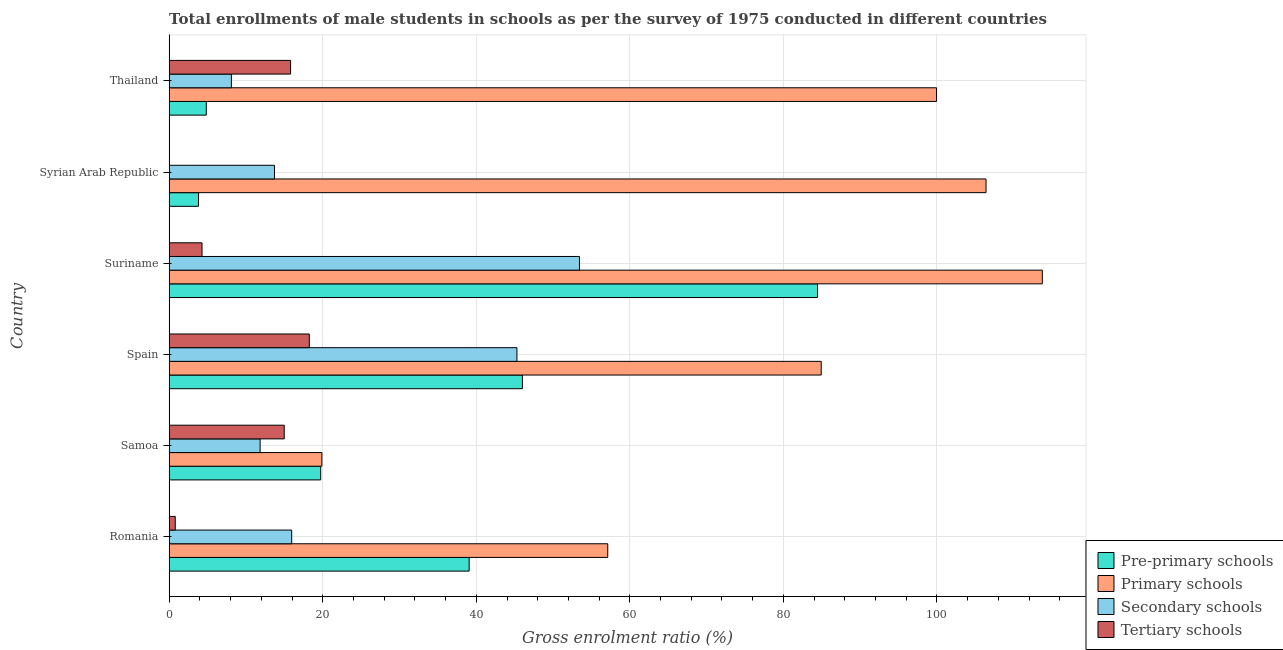Are the number of bars per tick equal to the number of legend labels?
Give a very brief answer. Yes. Are the number of bars on each tick of the Y-axis equal?
Keep it short and to the point. Yes. How many bars are there on the 5th tick from the top?
Offer a terse response. 4. How many bars are there on the 6th tick from the bottom?
Your answer should be very brief. 4. What is the label of the 5th group of bars from the top?
Your answer should be compact. Samoa. In how many cases, is the number of bars for a given country not equal to the number of legend labels?
Offer a terse response. 0. What is the gross enrolment ratio(male) in secondary schools in Syrian Arab Republic?
Your answer should be very brief. 13.72. Across all countries, what is the maximum gross enrolment ratio(male) in tertiary schools?
Provide a short and direct response. 18.25. Across all countries, what is the minimum gross enrolment ratio(male) in pre-primary schools?
Make the answer very short. 3.82. In which country was the gross enrolment ratio(male) in primary schools maximum?
Provide a succinct answer. Suriname. In which country was the gross enrolment ratio(male) in tertiary schools minimum?
Provide a short and direct response. Syrian Arab Republic. What is the total gross enrolment ratio(male) in pre-primary schools in the graph?
Your response must be concise. 197.89. What is the difference between the gross enrolment ratio(male) in tertiary schools in Spain and that in Thailand?
Offer a very short reply. 2.44. What is the difference between the gross enrolment ratio(male) in primary schools in Syrian Arab Republic and the gross enrolment ratio(male) in secondary schools in Thailand?
Your response must be concise. 98.29. What is the average gross enrolment ratio(male) in pre-primary schools per country?
Your answer should be very brief. 32.98. What is the difference between the gross enrolment ratio(male) in secondary schools and gross enrolment ratio(male) in pre-primary schools in Suriname?
Your response must be concise. -31.01. What is the ratio of the gross enrolment ratio(male) in pre-primary schools in Samoa to that in Suriname?
Provide a succinct answer. 0.23. Is the difference between the gross enrolment ratio(male) in primary schools in Spain and Syrian Arab Republic greater than the difference between the gross enrolment ratio(male) in pre-primary schools in Spain and Syrian Arab Republic?
Your answer should be compact. No. What is the difference between the highest and the second highest gross enrolment ratio(male) in primary schools?
Ensure brevity in your answer.  7.33. What is the difference between the highest and the lowest gross enrolment ratio(male) in secondary schools?
Keep it short and to the point. 45.34. In how many countries, is the gross enrolment ratio(male) in primary schools greater than the average gross enrolment ratio(male) in primary schools taken over all countries?
Provide a short and direct response. 4. Is the sum of the gross enrolment ratio(male) in primary schools in Romania and Syrian Arab Republic greater than the maximum gross enrolment ratio(male) in secondary schools across all countries?
Give a very brief answer. Yes. What does the 3rd bar from the top in Thailand represents?
Provide a short and direct response. Primary schools. What does the 2nd bar from the bottom in Romania represents?
Provide a succinct answer. Primary schools. Are all the bars in the graph horizontal?
Your answer should be compact. Yes. Are the values on the major ticks of X-axis written in scientific E-notation?
Offer a terse response. No. What is the title of the graph?
Provide a short and direct response. Total enrollments of male students in schools as per the survey of 1975 conducted in different countries. Does "Pre-primary schools" appear as one of the legend labels in the graph?
Offer a terse response. Yes. What is the label or title of the Y-axis?
Ensure brevity in your answer.  Country. What is the Gross enrolment ratio (%) of Pre-primary schools in Romania?
Keep it short and to the point. 39.07. What is the Gross enrolment ratio (%) in Primary schools in Romania?
Offer a terse response. 57.12. What is the Gross enrolment ratio (%) in Secondary schools in Romania?
Ensure brevity in your answer.  15.95. What is the Gross enrolment ratio (%) of Tertiary schools in Romania?
Offer a terse response. 0.79. What is the Gross enrolment ratio (%) in Pre-primary schools in Samoa?
Ensure brevity in your answer.  19.73. What is the Gross enrolment ratio (%) in Primary schools in Samoa?
Your answer should be very brief. 19.88. What is the Gross enrolment ratio (%) of Secondary schools in Samoa?
Offer a terse response. 11.84. What is the Gross enrolment ratio (%) of Tertiary schools in Samoa?
Give a very brief answer. 14.98. What is the Gross enrolment ratio (%) of Pre-primary schools in Spain?
Offer a very short reply. 46.01. What is the Gross enrolment ratio (%) of Primary schools in Spain?
Ensure brevity in your answer.  84.92. What is the Gross enrolment ratio (%) in Secondary schools in Spain?
Your response must be concise. 45.29. What is the Gross enrolment ratio (%) of Tertiary schools in Spain?
Give a very brief answer. 18.25. What is the Gross enrolment ratio (%) in Pre-primary schools in Suriname?
Your answer should be compact. 84.44. What is the Gross enrolment ratio (%) of Primary schools in Suriname?
Give a very brief answer. 113.72. What is the Gross enrolment ratio (%) in Secondary schools in Suriname?
Provide a short and direct response. 53.44. What is the Gross enrolment ratio (%) of Tertiary schools in Suriname?
Make the answer very short. 4.27. What is the Gross enrolment ratio (%) of Pre-primary schools in Syrian Arab Republic?
Your answer should be compact. 3.82. What is the Gross enrolment ratio (%) in Primary schools in Syrian Arab Republic?
Provide a succinct answer. 106.39. What is the Gross enrolment ratio (%) in Secondary schools in Syrian Arab Republic?
Your answer should be compact. 13.72. What is the Gross enrolment ratio (%) of Tertiary schools in Syrian Arab Republic?
Offer a terse response. 0.02. What is the Gross enrolment ratio (%) in Pre-primary schools in Thailand?
Provide a succinct answer. 4.83. What is the Gross enrolment ratio (%) of Primary schools in Thailand?
Provide a succinct answer. 99.95. What is the Gross enrolment ratio (%) of Secondary schools in Thailand?
Provide a succinct answer. 8.1. What is the Gross enrolment ratio (%) in Tertiary schools in Thailand?
Your answer should be very brief. 15.81. Across all countries, what is the maximum Gross enrolment ratio (%) in Pre-primary schools?
Your answer should be compact. 84.44. Across all countries, what is the maximum Gross enrolment ratio (%) in Primary schools?
Your answer should be compact. 113.72. Across all countries, what is the maximum Gross enrolment ratio (%) in Secondary schools?
Keep it short and to the point. 53.44. Across all countries, what is the maximum Gross enrolment ratio (%) of Tertiary schools?
Your response must be concise. 18.25. Across all countries, what is the minimum Gross enrolment ratio (%) in Pre-primary schools?
Keep it short and to the point. 3.82. Across all countries, what is the minimum Gross enrolment ratio (%) of Primary schools?
Make the answer very short. 19.88. Across all countries, what is the minimum Gross enrolment ratio (%) of Secondary schools?
Provide a succinct answer. 8.1. Across all countries, what is the minimum Gross enrolment ratio (%) in Tertiary schools?
Ensure brevity in your answer.  0.02. What is the total Gross enrolment ratio (%) of Pre-primary schools in the graph?
Provide a succinct answer. 197.89. What is the total Gross enrolment ratio (%) of Primary schools in the graph?
Keep it short and to the point. 481.99. What is the total Gross enrolment ratio (%) in Secondary schools in the graph?
Your answer should be very brief. 148.34. What is the total Gross enrolment ratio (%) of Tertiary schools in the graph?
Offer a very short reply. 54.12. What is the difference between the Gross enrolment ratio (%) of Pre-primary schools in Romania and that in Samoa?
Offer a very short reply. 19.34. What is the difference between the Gross enrolment ratio (%) of Primary schools in Romania and that in Samoa?
Make the answer very short. 37.24. What is the difference between the Gross enrolment ratio (%) in Secondary schools in Romania and that in Samoa?
Offer a very short reply. 4.11. What is the difference between the Gross enrolment ratio (%) of Tertiary schools in Romania and that in Samoa?
Provide a succinct answer. -14.19. What is the difference between the Gross enrolment ratio (%) in Pre-primary schools in Romania and that in Spain?
Your response must be concise. -6.94. What is the difference between the Gross enrolment ratio (%) in Primary schools in Romania and that in Spain?
Provide a succinct answer. -27.8. What is the difference between the Gross enrolment ratio (%) of Secondary schools in Romania and that in Spain?
Your answer should be compact. -29.34. What is the difference between the Gross enrolment ratio (%) of Tertiary schools in Romania and that in Spain?
Provide a short and direct response. -17.46. What is the difference between the Gross enrolment ratio (%) of Pre-primary schools in Romania and that in Suriname?
Your answer should be compact. -45.38. What is the difference between the Gross enrolment ratio (%) in Primary schools in Romania and that in Suriname?
Offer a very short reply. -56.6. What is the difference between the Gross enrolment ratio (%) of Secondary schools in Romania and that in Suriname?
Give a very brief answer. -37.48. What is the difference between the Gross enrolment ratio (%) in Tertiary schools in Romania and that in Suriname?
Give a very brief answer. -3.49. What is the difference between the Gross enrolment ratio (%) of Pre-primary schools in Romania and that in Syrian Arab Republic?
Ensure brevity in your answer.  35.25. What is the difference between the Gross enrolment ratio (%) of Primary schools in Romania and that in Syrian Arab Republic?
Offer a very short reply. -49.27. What is the difference between the Gross enrolment ratio (%) of Secondary schools in Romania and that in Syrian Arab Republic?
Give a very brief answer. 2.24. What is the difference between the Gross enrolment ratio (%) of Tertiary schools in Romania and that in Syrian Arab Republic?
Your answer should be very brief. 0.77. What is the difference between the Gross enrolment ratio (%) of Pre-primary schools in Romania and that in Thailand?
Make the answer very short. 34.24. What is the difference between the Gross enrolment ratio (%) in Primary schools in Romania and that in Thailand?
Make the answer very short. -42.83. What is the difference between the Gross enrolment ratio (%) in Secondary schools in Romania and that in Thailand?
Offer a very short reply. 7.86. What is the difference between the Gross enrolment ratio (%) of Tertiary schools in Romania and that in Thailand?
Your response must be concise. -15.02. What is the difference between the Gross enrolment ratio (%) in Pre-primary schools in Samoa and that in Spain?
Keep it short and to the point. -26.28. What is the difference between the Gross enrolment ratio (%) of Primary schools in Samoa and that in Spain?
Your response must be concise. -65.04. What is the difference between the Gross enrolment ratio (%) in Secondary schools in Samoa and that in Spain?
Your answer should be compact. -33.45. What is the difference between the Gross enrolment ratio (%) in Tertiary schools in Samoa and that in Spain?
Make the answer very short. -3.27. What is the difference between the Gross enrolment ratio (%) of Pre-primary schools in Samoa and that in Suriname?
Offer a terse response. -64.71. What is the difference between the Gross enrolment ratio (%) in Primary schools in Samoa and that in Suriname?
Offer a terse response. -93.84. What is the difference between the Gross enrolment ratio (%) of Secondary schools in Samoa and that in Suriname?
Your answer should be very brief. -41.6. What is the difference between the Gross enrolment ratio (%) of Tertiary schools in Samoa and that in Suriname?
Provide a succinct answer. 10.71. What is the difference between the Gross enrolment ratio (%) of Pre-primary schools in Samoa and that in Syrian Arab Republic?
Offer a very short reply. 15.92. What is the difference between the Gross enrolment ratio (%) of Primary schools in Samoa and that in Syrian Arab Republic?
Ensure brevity in your answer.  -86.51. What is the difference between the Gross enrolment ratio (%) of Secondary schools in Samoa and that in Syrian Arab Republic?
Make the answer very short. -1.88. What is the difference between the Gross enrolment ratio (%) in Tertiary schools in Samoa and that in Syrian Arab Republic?
Your answer should be compact. 14.96. What is the difference between the Gross enrolment ratio (%) in Pre-primary schools in Samoa and that in Thailand?
Keep it short and to the point. 14.9. What is the difference between the Gross enrolment ratio (%) of Primary schools in Samoa and that in Thailand?
Make the answer very short. -80.06. What is the difference between the Gross enrolment ratio (%) of Secondary schools in Samoa and that in Thailand?
Ensure brevity in your answer.  3.74. What is the difference between the Gross enrolment ratio (%) of Tertiary schools in Samoa and that in Thailand?
Make the answer very short. -0.83. What is the difference between the Gross enrolment ratio (%) of Pre-primary schools in Spain and that in Suriname?
Make the answer very short. -38.44. What is the difference between the Gross enrolment ratio (%) of Primary schools in Spain and that in Suriname?
Offer a terse response. -28.8. What is the difference between the Gross enrolment ratio (%) of Secondary schools in Spain and that in Suriname?
Your answer should be compact. -8.14. What is the difference between the Gross enrolment ratio (%) of Tertiary schools in Spain and that in Suriname?
Keep it short and to the point. 13.98. What is the difference between the Gross enrolment ratio (%) of Pre-primary schools in Spain and that in Syrian Arab Republic?
Your answer should be compact. 42.19. What is the difference between the Gross enrolment ratio (%) of Primary schools in Spain and that in Syrian Arab Republic?
Ensure brevity in your answer.  -21.47. What is the difference between the Gross enrolment ratio (%) of Secondary schools in Spain and that in Syrian Arab Republic?
Give a very brief answer. 31.58. What is the difference between the Gross enrolment ratio (%) of Tertiary schools in Spain and that in Syrian Arab Republic?
Offer a very short reply. 18.23. What is the difference between the Gross enrolment ratio (%) in Pre-primary schools in Spain and that in Thailand?
Provide a short and direct response. 41.18. What is the difference between the Gross enrolment ratio (%) in Primary schools in Spain and that in Thailand?
Offer a very short reply. -15.02. What is the difference between the Gross enrolment ratio (%) of Secondary schools in Spain and that in Thailand?
Offer a terse response. 37.19. What is the difference between the Gross enrolment ratio (%) of Tertiary schools in Spain and that in Thailand?
Provide a succinct answer. 2.44. What is the difference between the Gross enrolment ratio (%) of Pre-primary schools in Suriname and that in Syrian Arab Republic?
Your answer should be very brief. 80.63. What is the difference between the Gross enrolment ratio (%) in Primary schools in Suriname and that in Syrian Arab Republic?
Offer a very short reply. 7.33. What is the difference between the Gross enrolment ratio (%) in Secondary schools in Suriname and that in Syrian Arab Republic?
Keep it short and to the point. 39.72. What is the difference between the Gross enrolment ratio (%) of Tertiary schools in Suriname and that in Syrian Arab Republic?
Your answer should be compact. 4.26. What is the difference between the Gross enrolment ratio (%) of Pre-primary schools in Suriname and that in Thailand?
Your answer should be very brief. 79.61. What is the difference between the Gross enrolment ratio (%) of Primary schools in Suriname and that in Thailand?
Keep it short and to the point. 13.78. What is the difference between the Gross enrolment ratio (%) in Secondary schools in Suriname and that in Thailand?
Your answer should be compact. 45.34. What is the difference between the Gross enrolment ratio (%) in Tertiary schools in Suriname and that in Thailand?
Keep it short and to the point. -11.53. What is the difference between the Gross enrolment ratio (%) in Pre-primary schools in Syrian Arab Republic and that in Thailand?
Give a very brief answer. -1.01. What is the difference between the Gross enrolment ratio (%) of Primary schools in Syrian Arab Republic and that in Thailand?
Make the answer very short. 6.44. What is the difference between the Gross enrolment ratio (%) of Secondary schools in Syrian Arab Republic and that in Thailand?
Make the answer very short. 5.62. What is the difference between the Gross enrolment ratio (%) of Tertiary schools in Syrian Arab Republic and that in Thailand?
Offer a terse response. -15.79. What is the difference between the Gross enrolment ratio (%) in Pre-primary schools in Romania and the Gross enrolment ratio (%) in Primary schools in Samoa?
Give a very brief answer. 19.18. What is the difference between the Gross enrolment ratio (%) of Pre-primary schools in Romania and the Gross enrolment ratio (%) of Secondary schools in Samoa?
Give a very brief answer. 27.23. What is the difference between the Gross enrolment ratio (%) in Pre-primary schools in Romania and the Gross enrolment ratio (%) in Tertiary schools in Samoa?
Your response must be concise. 24.09. What is the difference between the Gross enrolment ratio (%) in Primary schools in Romania and the Gross enrolment ratio (%) in Secondary schools in Samoa?
Make the answer very short. 45.28. What is the difference between the Gross enrolment ratio (%) in Primary schools in Romania and the Gross enrolment ratio (%) in Tertiary schools in Samoa?
Offer a terse response. 42.14. What is the difference between the Gross enrolment ratio (%) of Secondary schools in Romania and the Gross enrolment ratio (%) of Tertiary schools in Samoa?
Provide a short and direct response. 0.97. What is the difference between the Gross enrolment ratio (%) in Pre-primary schools in Romania and the Gross enrolment ratio (%) in Primary schools in Spain?
Offer a terse response. -45.85. What is the difference between the Gross enrolment ratio (%) in Pre-primary schools in Romania and the Gross enrolment ratio (%) in Secondary schools in Spain?
Provide a short and direct response. -6.22. What is the difference between the Gross enrolment ratio (%) in Pre-primary schools in Romania and the Gross enrolment ratio (%) in Tertiary schools in Spain?
Provide a short and direct response. 20.82. What is the difference between the Gross enrolment ratio (%) in Primary schools in Romania and the Gross enrolment ratio (%) in Secondary schools in Spain?
Your answer should be compact. 11.83. What is the difference between the Gross enrolment ratio (%) of Primary schools in Romania and the Gross enrolment ratio (%) of Tertiary schools in Spain?
Provide a succinct answer. 38.87. What is the difference between the Gross enrolment ratio (%) in Secondary schools in Romania and the Gross enrolment ratio (%) in Tertiary schools in Spain?
Ensure brevity in your answer.  -2.3. What is the difference between the Gross enrolment ratio (%) of Pre-primary schools in Romania and the Gross enrolment ratio (%) of Primary schools in Suriname?
Your answer should be very brief. -74.66. What is the difference between the Gross enrolment ratio (%) in Pre-primary schools in Romania and the Gross enrolment ratio (%) in Secondary schools in Suriname?
Offer a very short reply. -14.37. What is the difference between the Gross enrolment ratio (%) in Pre-primary schools in Romania and the Gross enrolment ratio (%) in Tertiary schools in Suriname?
Provide a succinct answer. 34.79. What is the difference between the Gross enrolment ratio (%) in Primary schools in Romania and the Gross enrolment ratio (%) in Secondary schools in Suriname?
Your answer should be very brief. 3.68. What is the difference between the Gross enrolment ratio (%) in Primary schools in Romania and the Gross enrolment ratio (%) in Tertiary schools in Suriname?
Give a very brief answer. 52.85. What is the difference between the Gross enrolment ratio (%) in Secondary schools in Romania and the Gross enrolment ratio (%) in Tertiary schools in Suriname?
Your answer should be very brief. 11.68. What is the difference between the Gross enrolment ratio (%) in Pre-primary schools in Romania and the Gross enrolment ratio (%) in Primary schools in Syrian Arab Republic?
Your response must be concise. -67.32. What is the difference between the Gross enrolment ratio (%) in Pre-primary schools in Romania and the Gross enrolment ratio (%) in Secondary schools in Syrian Arab Republic?
Your answer should be compact. 25.35. What is the difference between the Gross enrolment ratio (%) in Pre-primary schools in Romania and the Gross enrolment ratio (%) in Tertiary schools in Syrian Arab Republic?
Your answer should be very brief. 39.05. What is the difference between the Gross enrolment ratio (%) of Primary schools in Romania and the Gross enrolment ratio (%) of Secondary schools in Syrian Arab Republic?
Ensure brevity in your answer.  43.41. What is the difference between the Gross enrolment ratio (%) of Primary schools in Romania and the Gross enrolment ratio (%) of Tertiary schools in Syrian Arab Republic?
Ensure brevity in your answer.  57.1. What is the difference between the Gross enrolment ratio (%) of Secondary schools in Romania and the Gross enrolment ratio (%) of Tertiary schools in Syrian Arab Republic?
Keep it short and to the point. 15.94. What is the difference between the Gross enrolment ratio (%) in Pre-primary schools in Romania and the Gross enrolment ratio (%) in Primary schools in Thailand?
Make the answer very short. -60.88. What is the difference between the Gross enrolment ratio (%) of Pre-primary schools in Romania and the Gross enrolment ratio (%) of Secondary schools in Thailand?
Provide a succinct answer. 30.97. What is the difference between the Gross enrolment ratio (%) of Pre-primary schools in Romania and the Gross enrolment ratio (%) of Tertiary schools in Thailand?
Keep it short and to the point. 23.26. What is the difference between the Gross enrolment ratio (%) of Primary schools in Romania and the Gross enrolment ratio (%) of Secondary schools in Thailand?
Offer a terse response. 49.02. What is the difference between the Gross enrolment ratio (%) in Primary schools in Romania and the Gross enrolment ratio (%) in Tertiary schools in Thailand?
Ensure brevity in your answer.  41.31. What is the difference between the Gross enrolment ratio (%) of Secondary schools in Romania and the Gross enrolment ratio (%) of Tertiary schools in Thailand?
Provide a short and direct response. 0.15. What is the difference between the Gross enrolment ratio (%) of Pre-primary schools in Samoa and the Gross enrolment ratio (%) of Primary schools in Spain?
Ensure brevity in your answer.  -65.19. What is the difference between the Gross enrolment ratio (%) in Pre-primary schools in Samoa and the Gross enrolment ratio (%) in Secondary schools in Spain?
Ensure brevity in your answer.  -25.56. What is the difference between the Gross enrolment ratio (%) of Pre-primary schools in Samoa and the Gross enrolment ratio (%) of Tertiary schools in Spain?
Provide a succinct answer. 1.48. What is the difference between the Gross enrolment ratio (%) in Primary schools in Samoa and the Gross enrolment ratio (%) in Secondary schools in Spain?
Your response must be concise. -25.41. What is the difference between the Gross enrolment ratio (%) of Primary schools in Samoa and the Gross enrolment ratio (%) of Tertiary schools in Spain?
Ensure brevity in your answer.  1.63. What is the difference between the Gross enrolment ratio (%) of Secondary schools in Samoa and the Gross enrolment ratio (%) of Tertiary schools in Spain?
Your response must be concise. -6.41. What is the difference between the Gross enrolment ratio (%) of Pre-primary schools in Samoa and the Gross enrolment ratio (%) of Primary schools in Suriname?
Offer a very short reply. -93.99. What is the difference between the Gross enrolment ratio (%) in Pre-primary schools in Samoa and the Gross enrolment ratio (%) in Secondary schools in Suriname?
Offer a very short reply. -33.71. What is the difference between the Gross enrolment ratio (%) of Pre-primary schools in Samoa and the Gross enrolment ratio (%) of Tertiary schools in Suriname?
Offer a very short reply. 15.46. What is the difference between the Gross enrolment ratio (%) of Primary schools in Samoa and the Gross enrolment ratio (%) of Secondary schools in Suriname?
Provide a short and direct response. -33.55. What is the difference between the Gross enrolment ratio (%) in Primary schools in Samoa and the Gross enrolment ratio (%) in Tertiary schools in Suriname?
Your answer should be compact. 15.61. What is the difference between the Gross enrolment ratio (%) of Secondary schools in Samoa and the Gross enrolment ratio (%) of Tertiary schools in Suriname?
Your response must be concise. 7.57. What is the difference between the Gross enrolment ratio (%) in Pre-primary schools in Samoa and the Gross enrolment ratio (%) in Primary schools in Syrian Arab Republic?
Your answer should be very brief. -86.66. What is the difference between the Gross enrolment ratio (%) of Pre-primary schools in Samoa and the Gross enrolment ratio (%) of Secondary schools in Syrian Arab Republic?
Offer a very short reply. 6.02. What is the difference between the Gross enrolment ratio (%) in Pre-primary schools in Samoa and the Gross enrolment ratio (%) in Tertiary schools in Syrian Arab Republic?
Your answer should be very brief. 19.71. What is the difference between the Gross enrolment ratio (%) in Primary schools in Samoa and the Gross enrolment ratio (%) in Secondary schools in Syrian Arab Republic?
Your response must be concise. 6.17. What is the difference between the Gross enrolment ratio (%) of Primary schools in Samoa and the Gross enrolment ratio (%) of Tertiary schools in Syrian Arab Republic?
Your answer should be compact. 19.87. What is the difference between the Gross enrolment ratio (%) in Secondary schools in Samoa and the Gross enrolment ratio (%) in Tertiary schools in Syrian Arab Republic?
Provide a succinct answer. 11.82. What is the difference between the Gross enrolment ratio (%) of Pre-primary schools in Samoa and the Gross enrolment ratio (%) of Primary schools in Thailand?
Ensure brevity in your answer.  -80.22. What is the difference between the Gross enrolment ratio (%) in Pre-primary schools in Samoa and the Gross enrolment ratio (%) in Secondary schools in Thailand?
Make the answer very short. 11.63. What is the difference between the Gross enrolment ratio (%) of Pre-primary schools in Samoa and the Gross enrolment ratio (%) of Tertiary schools in Thailand?
Give a very brief answer. 3.92. What is the difference between the Gross enrolment ratio (%) of Primary schools in Samoa and the Gross enrolment ratio (%) of Secondary schools in Thailand?
Offer a very short reply. 11.79. What is the difference between the Gross enrolment ratio (%) in Primary schools in Samoa and the Gross enrolment ratio (%) in Tertiary schools in Thailand?
Your response must be concise. 4.08. What is the difference between the Gross enrolment ratio (%) in Secondary schools in Samoa and the Gross enrolment ratio (%) in Tertiary schools in Thailand?
Offer a very short reply. -3.97. What is the difference between the Gross enrolment ratio (%) in Pre-primary schools in Spain and the Gross enrolment ratio (%) in Primary schools in Suriname?
Offer a terse response. -67.72. What is the difference between the Gross enrolment ratio (%) in Pre-primary schools in Spain and the Gross enrolment ratio (%) in Secondary schools in Suriname?
Your answer should be very brief. -7.43. What is the difference between the Gross enrolment ratio (%) in Pre-primary schools in Spain and the Gross enrolment ratio (%) in Tertiary schools in Suriname?
Your answer should be compact. 41.73. What is the difference between the Gross enrolment ratio (%) in Primary schools in Spain and the Gross enrolment ratio (%) in Secondary schools in Suriname?
Ensure brevity in your answer.  31.48. What is the difference between the Gross enrolment ratio (%) of Primary schools in Spain and the Gross enrolment ratio (%) of Tertiary schools in Suriname?
Offer a very short reply. 80.65. What is the difference between the Gross enrolment ratio (%) in Secondary schools in Spain and the Gross enrolment ratio (%) in Tertiary schools in Suriname?
Give a very brief answer. 41.02. What is the difference between the Gross enrolment ratio (%) of Pre-primary schools in Spain and the Gross enrolment ratio (%) of Primary schools in Syrian Arab Republic?
Give a very brief answer. -60.38. What is the difference between the Gross enrolment ratio (%) of Pre-primary schools in Spain and the Gross enrolment ratio (%) of Secondary schools in Syrian Arab Republic?
Ensure brevity in your answer.  32.29. What is the difference between the Gross enrolment ratio (%) in Pre-primary schools in Spain and the Gross enrolment ratio (%) in Tertiary schools in Syrian Arab Republic?
Give a very brief answer. 45.99. What is the difference between the Gross enrolment ratio (%) in Primary schools in Spain and the Gross enrolment ratio (%) in Secondary schools in Syrian Arab Republic?
Offer a very short reply. 71.21. What is the difference between the Gross enrolment ratio (%) in Primary schools in Spain and the Gross enrolment ratio (%) in Tertiary schools in Syrian Arab Republic?
Your answer should be compact. 84.9. What is the difference between the Gross enrolment ratio (%) in Secondary schools in Spain and the Gross enrolment ratio (%) in Tertiary schools in Syrian Arab Republic?
Your answer should be compact. 45.27. What is the difference between the Gross enrolment ratio (%) in Pre-primary schools in Spain and the Gross enrolment ratio (%) in Primary schools in Thailand?
Make the answer very short. -53.94. What is the difference between the Gross enrolment ratio (%) of Pre-primary schools in Spain and the Gross enrolment ratio (%) of Secondary schools in Thailand?
Your answer should be compact. 37.91. What is the difference between the Gross enrolment ratio (%) in Pre-primary schools in Spain and the Gross enrolment ratio (%) in Tertiary schools in Thailand?
Keep it short and to the point. 30.2. What is the difference between the Gross enrolment ratio (%) in Primary schools in Spain and the Gross enrolment ratio (%) in Secondary schools in Thailand?
Offer a terse response. 76.82. What is the difference between the Gross enrolment ratio (%) in Primary schools in Spain and the Gross enrolment ratio (%) in Tertiary schools in Thailand?
Provide a succinct answer. 69.11. What is the difference between the Gross enrolment ratio (%) in Secondary schools in Spain and the Gross enrolment ratio (%) in Tertiary schools in Thailand?
Make the answer very short. 29.48. What is the difference between the Gross enrolment ratio (%) of Pre-primary schools in Suriname and the Gross enrolment ratio (%) of Primary schools in Syrian Arab Republic?
Give a very brief answer. -21.95. What is the difference between the Gross enrolment ratio (%) of Pre-primary schools in Suriname and the Gross enrolment ratio (%) of Secondary schools in Syrian Arab Republic?
Keep it short and to the point. 70.73. What is the difference between the Gross enrolment ratio (%) in Pre-primary schools in Suriname and the Gross enrolment ratio (%) in Tertiary schools in Syrian Arab Republic?
Your response must be concise. 84.43. What is the difference between the Gross enrolment ratio (%) in Primary schools in Suriname and the Gross enrolment ratio (%) in Secondary schools in Syrian Arab Republic?
Your answer should be compact. 100.01. What is the difference between the Gross enrolment ratio (%) in Primary schools in Suriname and the Gross enrolment ratio (%) in Tertiary schools in Syrian Arab Republic?
Provide a succinct answer. 113.71. What is the difference between the Gross enrolment ratio (%) in Secondary schools in Suriname and the Gross enrolment ratio (%) in Tertiary schools in Syrian Arab Republic?
Make the answer very short. 53.42. What is the difference between the Gross enrolment ratio (%) in Pre-primary schools in Suriname and the Gross enrolment ratio (%) in Primary schools in Thailand?
Your answer should be compact. -15.5. What is the difference between the Gross enrolment ratio (%) of Pre-primary schools in Suriname and the Gross enrolment ratio (%) of Secondary schools in Thailand?
Your answer should be very brief. 76.34. What is the difference between the Gross enrolment ratio (%) of Pre-primary schools in Suriname and the Gross enrolment ratio (%) of Tertiary schools in Thailand?
Your response must be concise. 68.64. What is the difference between the Gross enrolment ratio (%) of Primary schools in Suriname and the Gross enrolment ratio (%) of Secondary schools in Thailand?
Provide a succinct answer. 105.63. What is the difference between the Gross enrolment ratio (%) of Primary schools in Suriname and the Gross enrolment ratio (%) of Tertiary schools in Thailand?
Your answer should be very brief. 97.92. What is the difference between the Gross enrolment ratio (%) in Secondary schools in Suriname and the Gross enrolment ratio (%) in Tertiary schools in Thailand?
Your response must be concise. 37.63. What is the difference between the Gross enrolment ratio (%) in Pre-primary schools in Syrian Arab Republic and the Gross enrolment ratio (%) in Primary schools in Thailand?
Make the answer very short. -96.13. What is the difference between the Gross enrolment ratio (%) of Pre-primary schools in Syrian Arab Republic and the Gross enrolment ratio (%) of Secondary schools in Thailand?
Your response must be concise. -4.28. What is the difference between the Gross enrolment ratio (%) of Pre-primary schools in Syrian Arab Republic and the Gross enrolment ratio (%) of Tertiary schools in Thailand?
Offer a terse response. -11.99. What is the difference between the Gross enrolment ratio (%) in Primary schools in Syrian Arab Republic and the Gross enrolment ratio (%) in Secondary schools in Thailand?
Make the answer very short. 98.29. What is the difference between the Gross enrolment ratio (%) of Primary schools in Syrian Arab Republic and the Gross enrolment ratio (%) of Tertiary schools in Thailand?
Provide a succinct answer. 90.58. What is the difference between the Gross enrolment ratio (%) in Secondary schools in Syrian Arab Republic and the Gross enrolment ratio (%) in Tertiary schools in Thailand?
Provide a succinct answer. -2.09. What is the average Gross enrolment ratio (%) in Pre-primary schools per country?
Your response must be concise. 32.98. What is the average Gross enrolment ratio (%) of Primary schools per country?
Your answer should be very brief. 80.33. What is the average Gross enrolment ratio (%) of Secondary schools per country?
Ensure brevity in your answer.  24.72. What is the average Gross enrolment ratio (%) of Tertiary schools per country?
Your answer should be very brief. 9.02. What is the difference between the Gross enrolment ratio (%) in Pre-primary schools and Gross enrolment ratio (%) in Primary schools in Romania?
Your answer should be very brief. -18.05. What is the difference between the Gross enrolment ratio (%) of Pre-primary schools and Gross enrolment ratio (%) of Secondary schools in Romania?
Ensure brevity in your answer.  23.11. What is the difference between the Gross enrolment ratio (%) in Pre-primary schools and Gross enrolment ratio (%) in Tertiary schools in Romania?
Provide a short and direct response. 38.28. What is the difference between the Gross enrolment ratio (%) of Primary schools and Gross enrolment ratio (%) of Secondary schools in Romania?
Keep it short and to the point. 41.17. What is the difference between the Gross enrolment ratio (%) in Primary schools and Gross enrolment ratio (%) in Tertiary schools in Romania?
Provide a succinct answer. 56.33. What is the difference between the Gross enrolment ratio (%) of Secondary schools and Gross enrolment ratio (%) of Tertiary schools in Romania?
Your answer should be compact. 15.17. What is the difference between the Gross enrolment ratio (%) of Pre-primary schools and Gross enrolment ratio (%) of Primary schools in Samoa?
Your response must be concise. -0.15. What is the difference between the Gross enrolment ratio (%) in Pre-primary schools and Gross enrolment ratio (%) in Secondary schools in Samoa?
Keep it short and to the point. 7.89. What is the difference between the Gross enrolment ratio (%) of Pre-primary schools and Gross enrolment ratio (%) of Tertiary schools in Samoa?
Provide a short and direct response. 4.75. What is the difference between the Gross enrolment ratio (%) of Primary schools and Gross enrolment ratio (%) of Secondary schools in Samoa?
Make the answer very short. 8.04. What is the difference between the Gross enrolment ratio (%) in Primary schools and Gross enrolment ratio (%) in Tertiary schools in Samoa?
Your answer should be compact. 4.9. What is the difference between the Gross enrolment ratio (%) in Secondary schools and Gross enrolment ratio (%) in Tertiary schools in Samoa?
Your response must be concise. -3.14. What is the difference between the Gross enrolment ratio (%) in Pre-primary schools and Gross enrolment ratio (%) in Primary schools in Spain?
Offer a terse response. -38.92. What is the difference between the Gross enrolment ratio (%) in Pre-primary schools and Gross enrolment ratio (%) in Secondary schools in Spain?
Offer a terse response. 0.71. What is the difference between the Gross enrolment ratio (%) in Pre-primary schools and Gross enrolment ratio (%) in Tertiary schools in Spain?
Your answer should be very brief. 27.76. What is the difference between the Gross enrolment ratio (%) of Primary schools and Gross enrolment ratio (%) of Secondary schools in Spain?
Offer a very short reply. 39.63. What is the difference between the Gross enrolment ratio (%) of Primary schools and Gross enrolment ratio (%) of Tertiary schools in Spain?
Your answer should be very brief. 66.67. What is the difference between the Gross enrolment ratio (%) of Secondary schools and Gross enrolment ratio (%) of Tertiary schools in Spain?
Ensure brevity in your answer.  27.04. What is the difference between the Gross enrolment ratio (%) in Pre-primary schools and Gross enrolment ratio (%) in Primary schools in Suriname?
Your answer should be compact. -29.28. What is the difference between the Gross enrolment ratio (%) of Pre-primary schools and Gross enrolment ratio (%) of Secondary schools in Suriname?
Keep it short and to the point. 31.01. What is the difference between the Gross enrolment ratio (%) of Pre-primary schools and Gross enrolment ratio (%) of Tertiary schools in Suriname?
Ensure brevity in your answer.  80.17. What is the difference between the Gross enrolment ratio (%) in Primary schools and Gross enrolment ratio (%) in Secondary schools in Suriname?
Keep it short and to the point. 60.29. What is the difference between the Gross enrolment ratio (%) of Primary schools and Gross enrolment ratio (%) of Tertiary schools in Suriname?
Your answer should be very brief. 109.45. What is the difference between the Gross enrolment ratio (%) of Secondary schools and Gross enrolment ratio (%) of Tertiary schools in Suriname?
Offer a terse response. 49.16. What is the difference between the Gross enrolment ratio (%) of Pre-primary schools and Gross enrolment ratio (%) of Primary schools in Syrian Arab Republic?
Your answer should be compact. -102.58. What is the difference between the Gross enrolment ratio (%) of Pre-primary schools and Gross enrolment ratio (%) of Secondary schools in Syrian Arab Republic?
Offer a very short reply. -9.9. What is the difference between the Gross enrolment ratio (%) of Pre-primary schools and Gross enrolment ratio (%) of Tertiary schools in Syrian Arab Republic?
Your answer should be very brief. 3.8. What is the difference between the Gross enrolment ratio (%) of Primary schools and Gross enrolment ratio (%) of Secondary schools in Syrian Arab Republic?
Your answer should be compact. 92.68. What is the difference between the Gross enrolment ratio (%) of Primary schools and Gross enrolment ratio (%) of Tertiary schools in Syrian Arab Republic?
Offer a very short reply. 106.37. What is the difference between the Gross enrolment ratio (%) in Secondary schools and Gross enrolment ratio (%) in Tertiary schools in Syrian Arab Republic?
Make the answer very short. 13.7. What is the difference between the Gross enrolment ratio (%) in Pre-primary schools and Gross enrolment ratio (%) in Primary schools in Thailand?
Keep it short and to the point. -95.12. What is the difference between the Gross enrolment ratio (%) of Pre-primary schools and Gross enrolment ratio (%) of Secondary schools in Thailand?
Your answer should be compact. -3.27. What is the difference between the Gross enrolment ratio (%) of Pre-primary schools and Gross enrolment ratio (%) of Tertiary schools in Thailand?
Ensure brevity in your answer.  -10.98. What is the difference between the Gross enrolment ratio (%) of Primary schools and Gross enrolment ratio (%) of Secondary schools in Thailand?
Keep it short and to the point. 91.85. What is the difference between the Gross enrolment ratio (%) of Primary schools and Gross enrolment ratio (%) of Tertiary schools in Thailand?
Your answer should be compact. 84.14. What is the difference between the Gross enrolment ratio (%) of Secondary schools and Gross enrolment ratio (%) of Tertiary schools in Thailand?
Your answer should be compact. -7.71. What is the ratio of the Gross enrolment ratio (%) in Pre-primary schools in Romania to that in Samoa?
Provide a short and direct response. 1.98. What is the ratio of the Gross enrolment ratio (%) of Primary schools in Romania to that in Samoa?
Give a very brief answer. 2.87. What is the ratio of the Gross enrolment ratio (%) of Secondary schools in Romania to that in Samoa?
Your answer should be compact. 1.35. What is the ratio of the Gross enrolment ratio (%) of Tertiary schools in Romania to that in Samoa?
Keep it short and to the point. 0.05. What is the ratio of the Gross enrolment ratio (%) in Pre-primary schools in Romania to that in Spain?
Your answer should be very brief. 0.85. What is the ratio of the Gross enrolment ratio (%) in Primary schools in Romania to that in Spain?
Keep it short and to the point. 0.67. What is the ratio of the Gross enrolment ratio (%) in Secondary schools in Romania to that in Spain?
Give a very brief answer. 0.35. What is the ratio of the Gross enrolment ratio (%) of Tertiary schools in Romania to that in Spain?
Offer a very short reply. 0.04. What is the ratio of the Gross enrolment ratio (%) in Pre-primary schools in Romania to that in Suriname?
Keep it short and to the point. 0.46. What is the ratio of the Gross enrolment ratio (%) in Primary schools in Romania to that in Suriname?
Offer a very short reply. 0.5. What is the ratio of the Gross enrolment ratio (%) of Secondary schools in Romania to that in Suriname?
Give a very brief answer. 0.3. What is the ratio of the Gross enrolment ratio (%) in Tertiary schools in Romania to that in Suriname?
Keep it short and to the point. 0.18. What is the ratio of the Gross enrolment ratio (%) of Pre-primary schools in Romania to that in Syrian Arab Republic?
Provide a succinct answer. 10.24. What is the ratio of the Gross enrolment ratio (%) in Primary schools in Romania to that in Syrian Arab Republic?
Your response must be concise. 0.54. What is the ratio of the Gross enrolment ratio (%) of Secondary schools in Romania to that in Syrian Arab Republic?
Your answer should be very brief. 1.16. What is the ratio of the Gross enrolment ratio (%) of Tertiary schools in Romania to that in Syrian Arab Republic?
Your answer should be compact. 43. What is the ratio of the Gross enrolment ratio (%) of Pre-primary schools in Romania to that in Thailand?
Your answer should be compact. 8.09. What is the ratio of the Gross enrolment ratio (%) of Primary schools in Romania to that in Thailand?
Your answer should be compact. 0.57. What is the ratio of the Gross enrolment ratio (%) in Secondary schools in Romania to that in Thailand?
Make the answer very short. 1.97. What is the ratio of the Gross enrolment ratio (%) of Tertiary schools in Romania to that in Thailand?
Provide a short and direct response. 0.05. What is the ratio of the Gross enrolment ratio (%) in Pre-primary schools in Samoa to that in Spain?
Offer a terse response. 0.43. What is the ratio of the Gross enrolment ratio (%) of Primary schools in Samoa to that in Spain?
Your answer should be very brief. 0.23. What is the ratio of the Gross enrolment ratio (%) of Secondary schools in Samoa to that in Spain?
Your response must be concise. 0.26. What is the ratio of the Gross enrolment ratio (%) in Tertiary schools in Samoa to that in Spain?
Make the answer very short. 0.82. What is the ratio of the Gross enrolment ratio (%) in Pre-primary schools in Samoa to that in Suriname?
Your answer should be very brief. 0.23. What is the ratio of the Gross enrolment ratio (%) in Primary schools in Samoa to that in Suriname?
Keep it short and to the point. 0.17. What is the ratio of the Gross enrolment ratio (%) of Secondary schools in Samoa to that in Suriname?
Your answer should be very brief. 0.22. What is the ratio of the Gross enrolment ratio (%) of Tertiary schools in Samoa to that in Suriname?
Your response must be concise. 3.51. What is the ratio of the Gross enrolment ratio (%) of Pre-primary schools in Samoa to that in Syrian Arab Republic?
Give a very brief answer. 5.17. What is the ratio of the Gross enrolment ratio (%) in Primary schools in Samoa to that in Syrian Arab Republic?
Your answer should be very brief. 0.19. What is the ratio of the Gross enrolment ratio (%) in Secondary schools in Samoa to that in Syrian Arab Republic?
Make the answer very short. 0.86. What is the ratio of the Gross enrolment ratio (%) of Tertiary schools in Samoa to that in Syrian Arab Republic?
Your answer should be very brief. 817.72. What is the ratio of the Gross enrolment ratio (%) in Pre-primary schools in Samoa to that in Thailand?
Offer a terse response. 4.08. What is the ratio of the Gross enrolment ratio (%) in Primary schools in Samoa to that in Thailand?
Provide a succinct answer. 0.2. What is the ratio of the Gross enrolment ratio (%) of Secondary schools in Samoa to that in Thailand?
Offer a terse response. 1.46. What is the ratio of the Gross enrolment ratio (%) in Tertiary schools in Samoa to that in Thailand?
Ensure brevity in your answer.  0.95. What is the ratio of the Gross enrolment ratio (%) of Pre-primary schools in Spain to that in Suriname?
Provide a succinct answer. 0.54. What is the ratio of the Gross enrolment ratio (%) in Primary schools in Spain to that in Suriname?
Your response must be concise. 0.75. What is the ratio of the Gross enrolment ratio (%) in Secondary schools in Spain to that in Suriname?
Provide a succinct answer. 0.85. What is the ratio of the Gross enrolment ratio (%) of Tertiary schools in Spain to that in Suriname?
Your answer should be compact. 4.27. What is the ratio of the Gross enrolment ratio (%) in Pre-primary schools in Spain to that in Syrian Arab Republic?
Make the answer very short. 12.06. What is the ratio of the Gross enrolment ratio (%) in Primary schools in Spain to that in Syrian Arab Republic?
Ensure brevity in your answer.  0.8. What is the ratio of the Gross enrolment ratio (%) in Secondary schools in Spain to that in Syrian Arab Republic?
Your response must be concise. 3.3. What is the ratio of the Gross enrolment ratio (%) in Tertiary schools in Spain to that in Syrian Arab Republic?
Your response must be concise. 996.17. What is the ratio of the Gross enrolment ratio (%) in Pre-primary schools in Spain to that in Thailand?
Offer a very short reply. 9.53. What is the ratio of the Gross enrolment ratio (%) in Primary schools in Spain to that in Thailand?
Provide a succinct answer. 0.85. What is the ratio of the Gross enrolment ratio (%) in Secondary schools in Spain to that in Thailand?
Provide a short and direct response. 5.59. What is the ratio of the Gross enrolment ratio (%) in Tertiary schools in Spain to that in Thailand?
Provide a short and direct response. 1.15. What is the ratio of the Gross enrolment ratio (%) of Pre-primary schools in Suriname to that in Syrian Arab Republic?
Give a very brief answer. 22.13. What is the ratio of the Gross enrolment ratio (%) of Primary schools in Suriname to that in Syrian Arab Republic?
Your answer should be compact. 1.07. What is the ratio of the Gross enrolment ratio (%) of Secondary schools in Suriname to that in Syrian Arab Republic?
Offer a very short reply. 3.9. What is the ratio of the Gross enrolment ratio (%) of Tertiary schools in Suriname to that in Syrian Arab Republic?
Provide a short and direct response. 233.27. What is the ratio of the Gross enrolment ratio (%) of Pre-primary schools in Suriname to that in Thailand?
Give a very brief answer. 17.48. What is the ratio of the Gross enrolment ratio (%) in Primary schools in Suriname to that in Thailand?
Give a very brief answer. 1.14. What is the ratio of the Gross enrolment ratio (%) of Secondary schools in Suriname to that in Thailand?
Make the answer very short. 6.6. What is the ratio of the Gross enrolment ratio (%) in Tertiary schools in Suriname to that in Thailand?
Offer a terse response. 0.27. What is the ratio of the Gross enrolment ratio (%) in Pre-primary schools in Syrian Arab Republic to that in Thailand?
Your answer should be compact. 0.79. What is the ratio of the Gross enrolment ratio (%) of Primary schools in Syrian Arab Republic to that in Thailand?
Your answer should be very brief. 1.06. What is the ratio of the Gross enrolment ratio (%) of Secondary schools in Syrian Arab Republic to that in Thailand?
Provide a short and direct response. 1.69. What is the ratio of the Gross enrolment ratio (%) in Tertiary schools in Syrian Arab Republic to that in Thailand?
Offer a very short reply. 0. What is the difference between the highest and the second highest Gross enrolment ratio (%) of Pre-primary schools?
Offer a terse response. 38.44. What is the difference between the highest and the second highest Gross enrolment ratio (%) of Primary schools?
Give a very brief answer. 7.33. What is the difference between the highest and the second highest Gross enrolment ratio (%) of Secondary schools?
Give a very brief answer. 8.14. What is the difference between the highest and the second highest Gross enrolment ratio (%) of Tertiary schools?
Offer a terse response. 2.44. What is the difference between the highest and the lowest Gross enrolment ratio (%) in Pre-primary schools?
Keep it short and to the point. 80.63. What is the difference between the highest and the lowest Gross enrolment ratio (%) of Primary schools?
Your answer should be very brief. 93.84. What is the difference between the highest and the lowest Gross enrolment ratio (%) in Secondary schools?
Your response must be concise. 45.34. What is the difference between the highest and the lowest Gross enrolment ratio (%) in Tertiary schools?
Give a very brief answer. 18.23. 